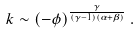<formula> <loc_0><loc_0><loc_500><loc_500>k \sim ( - \phi ) ^ { \frac { \gamma } { ( \gamma - 1 ) ( \alpha + \beta ) } } \, .</formula> 